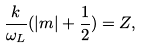Convert formula to latex. <formula><loc_0><loc_0><loc_500><loc_500>\frac { k } { \omega _ { L } } ( | m | + \frac { 1 } { 2 } ) = Z ,</formula> 